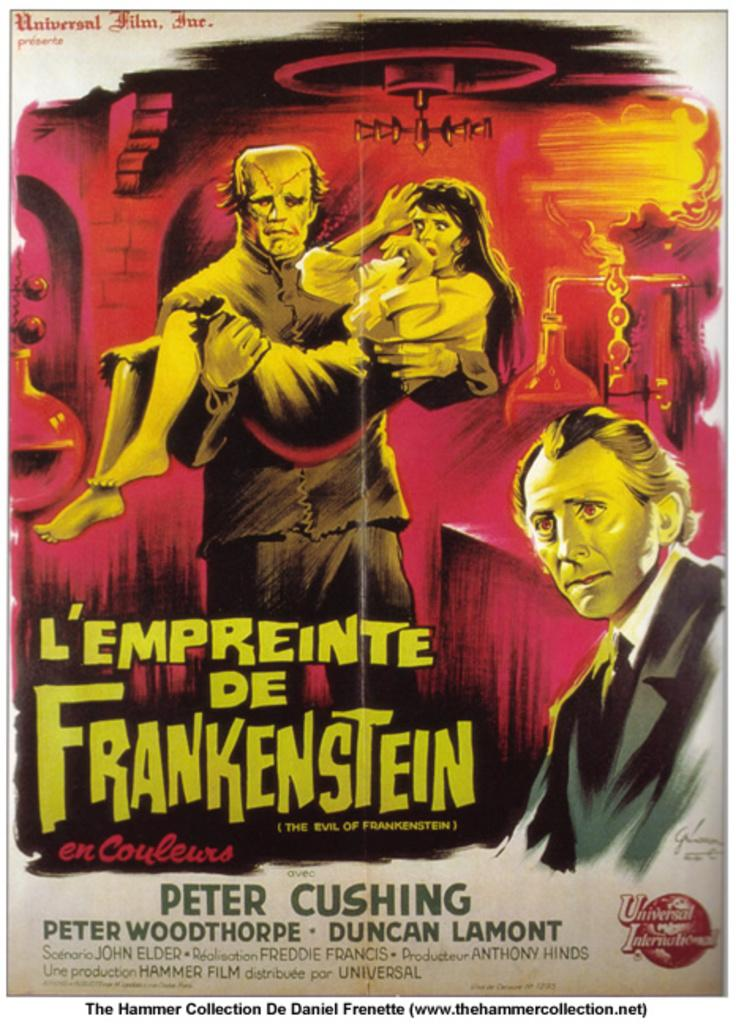<image>
Give a short and clear explanation of the subsequent image. A poster for a movie that stars Peter Cushing. 